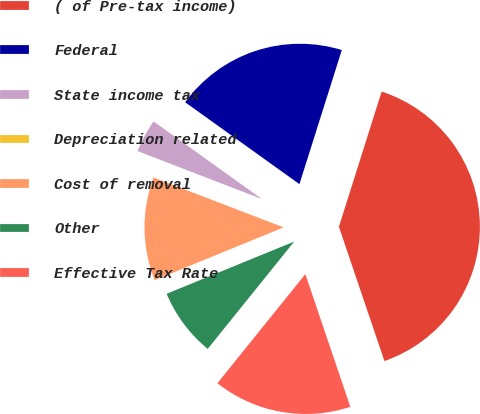Convert chart to OTSL. <chart><loc_0><loc_0><loc_500><loc_500><pie_chart><fcel>( of Pre-tax income)<fcel>Federal<fcel>State income tax<fcel>Depreciation related<fcel>Cost of removal<fcel>Other<fcel>Effective Tax Rate<nl><fcel>39.93%<fcel>19.98%<fcel>4.03%<fcel>0.04%<fcel>12.01%<fcel>8.02%<fcel>16.0%<nl></chart> 